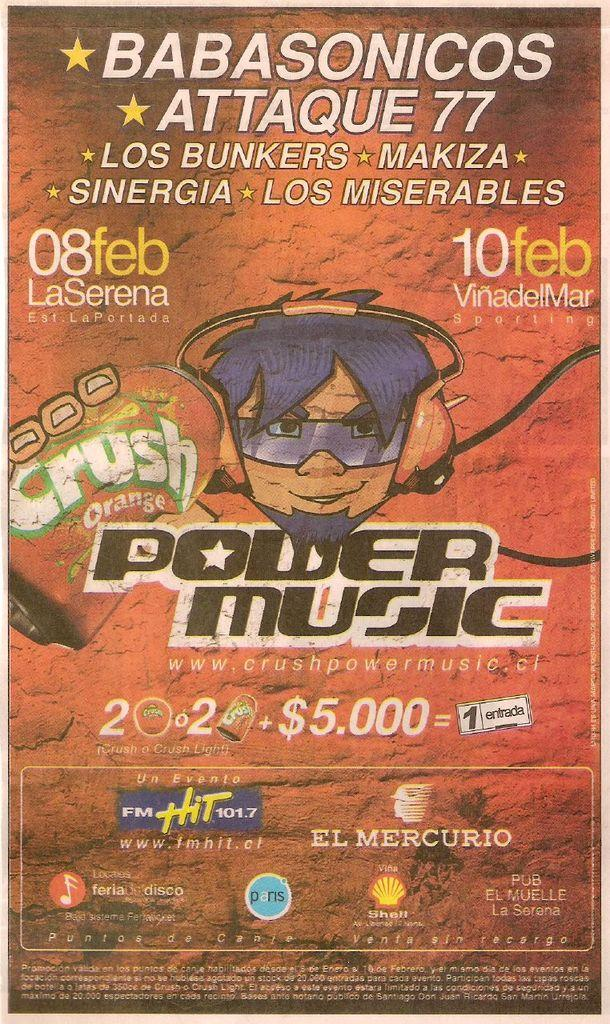<image>
Share a concise interpretation of the image provided. An advertisement for Power Music with other ads 